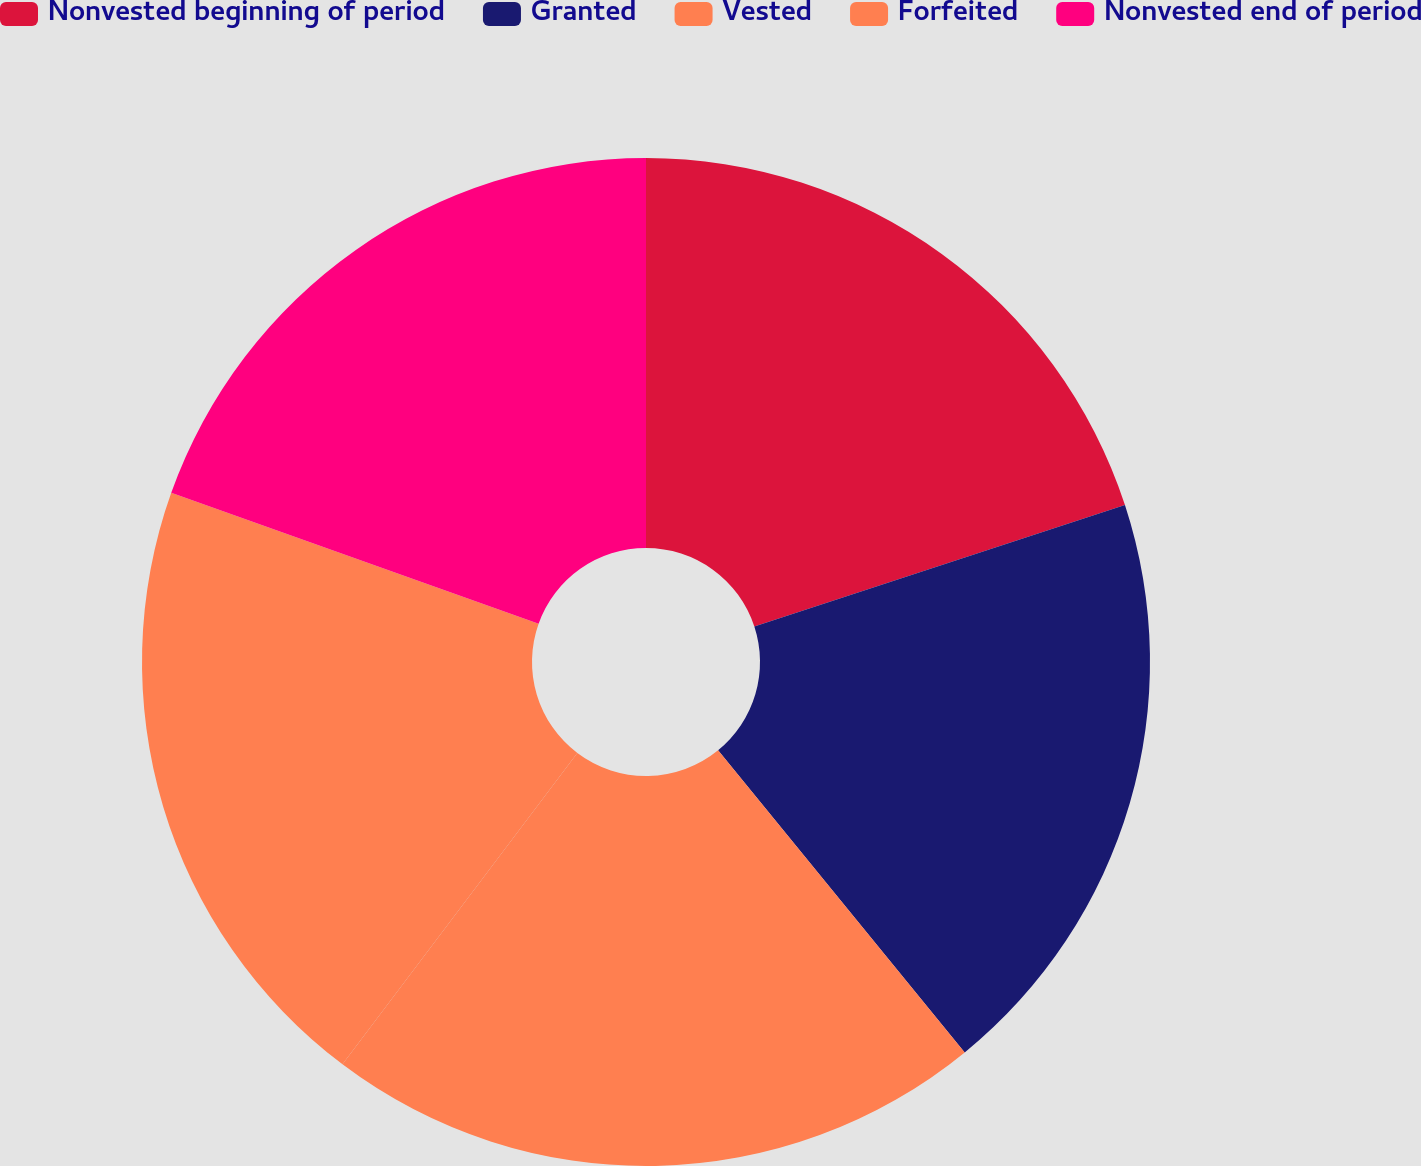<chart> <loc_0><loc_0><loc_500><loc_500><pie_chart><fcel>Nonvested beginning of period<fcel>Granted<fcel>Vested<fcel>Forfeited<fcel>Nonvested end of period<nl><fcel>19.96%<fcel>19.14%<fcel>21.18%<fcel>20.16%<fcel>19.55%<nl></chart> 